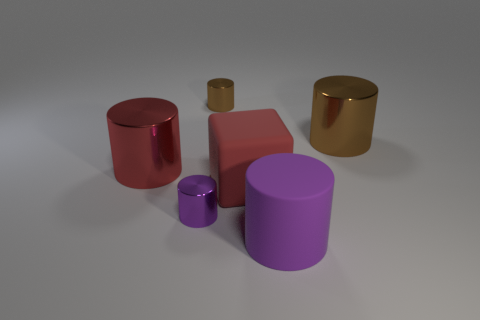Subtract all red cylinders. How many cylinders are left? 4 Subtract all purple cylinders. How many cylinders are left? 3 Add 4 big red rubber blocks. How many objects exist? 10 Subtract 3 cylinders. How many cylinders are left? 2 Subtract all cylinders. How many objects are left? 1 Add 1 large red things. How many large red things are left? 3 Add 5 big things. How many big things exist? 9 Subtract 0 gray cylinders. How many objects are left? 6 Subtract all cyan cylinders. Subtract all cyan blocks. How many cylinders are left? 5 Subtract all purple cylinders. How many yellow blocks are left? 0 